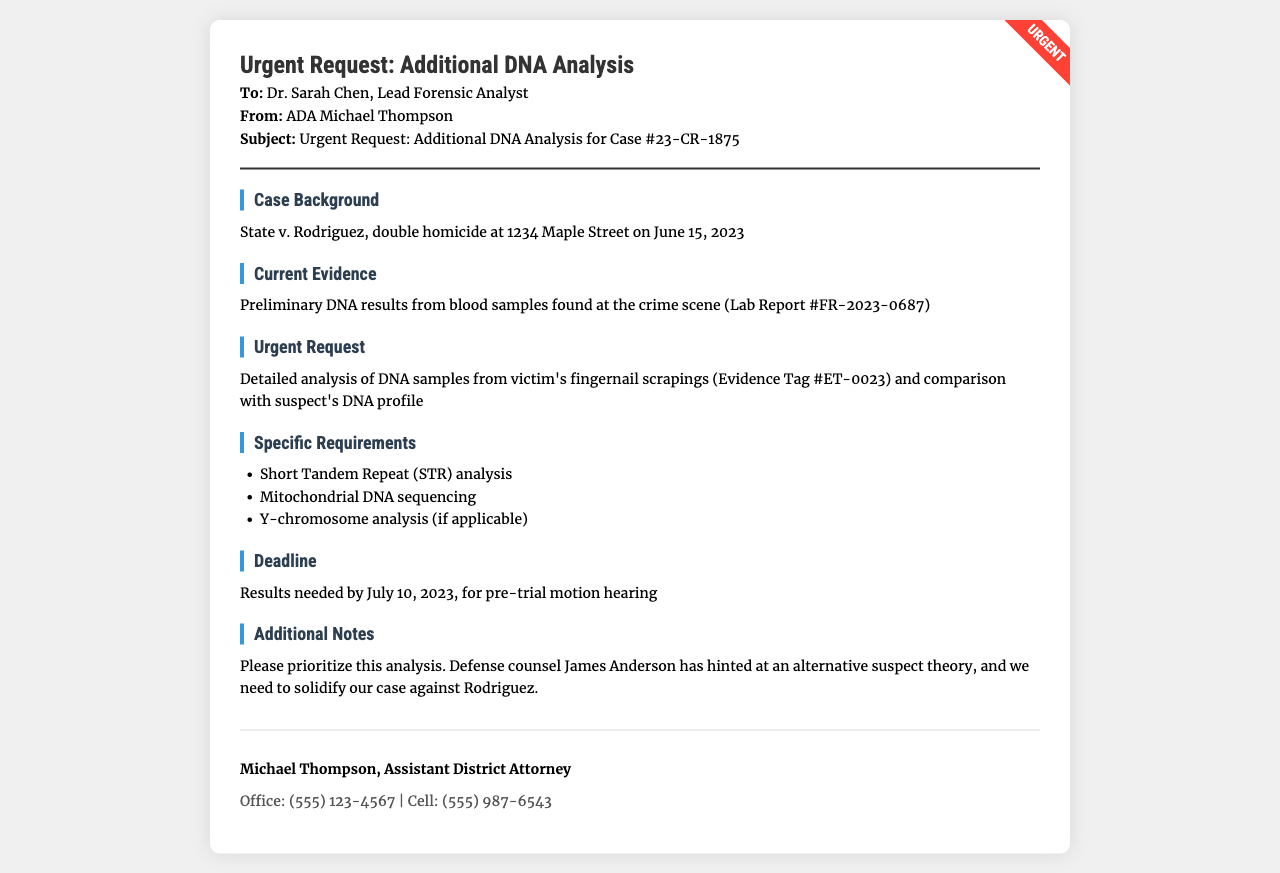what is the case number? The case number is mentioned in the subject line of the fax as Case #23-CR-1875.
Answer: Case #23-CR-1875 who is the sender of the fax? The sender of the fax is indicated in the "From" line as ADA Michael Thompson.
Answer: ADA Michael Thompson what is the deadline for the DNA results? The deadline for the results is specified as July 10, 2023.
Answer: July 10, 2023 what type of analysis is requested for the DNA samples? The request includes Detailed analysis of DNA samples from victim's fingernail scrapings and requires several specific types of analysis as listed.
Answer: STR analysis, mitochondrial DNA sequencing, Y-chromosome analysis who is the lead forensic analyst addressed in the fax? The lead forensic analyst is named in the "To" line as Dr. Sarah Chen.
Answer: Dr. Sarah Chen what is the date of the incident related to the case? The date of the incident is mentioned in the case background as June 15, 2023.
Answer: June 15, 2023 why is this DNA analysis considered urgent? This analysis is considered urgent due to hints from defense counsel about an alternative suspect theory, necessitating solid evidence against the suspect Rodriguez.
Answer: Solidify the case against Rodriguez which evidence tag number is associated with the fingernail scrapings? The evidence tag number for the fingernail scrapings is indicated as Evidence Tag #ET-0023.
Answer: Evidence Tag #ET-0023 